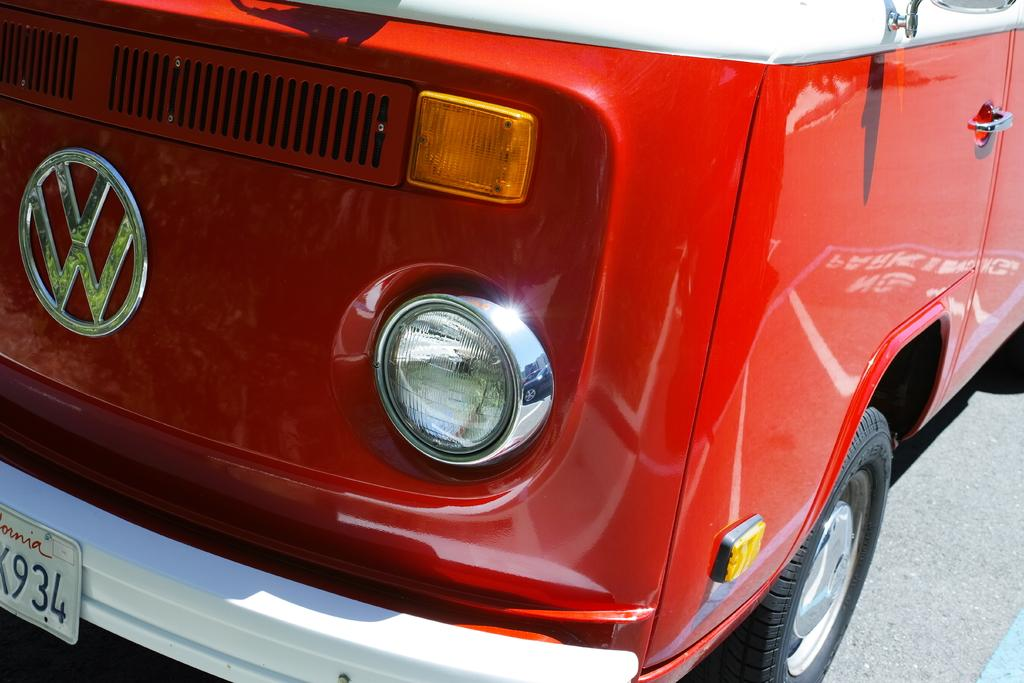What color is the vehicle in the image? The vehicle in the image is red. What else can be seen in the image besides the vehicle? There are numbers written on a board in the image. What type of bird can be seen sitting on the mailbox in the image? There is no mailbox or bird present in the image. What thrilling activity is taking place in the image? There is no thrilling activity depicted in the image; it features a red vehicle and numbers on a board. 